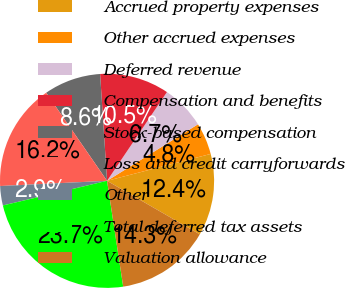Convert chart to OTSL. <chart><loc_0><loc_0><loc_500><loc_500><pie_chart><fcel>Accrued property expenses<fcel>Other accrued expenses<fcel>Deferred revenue<fcel>Compensation and benefits<fcel>Stock-based compensation<fcel>Loss and credit carryforwards<fcel>Other<fcel>Total deferred tax assets<fcel>Valuation allowance<nl><fcel>12.37%<fcel>4.81%<fcel>6.7%<fcel>10.48%<fcel>8.59%<fcel>16.15%<fcel>2.92%<fcel>23.71%<fcel>14.26%<nl></chart> 